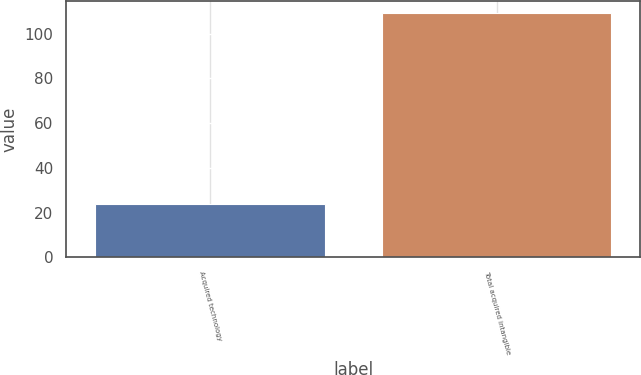<chart> <loc_0><loc_0><loc_500><loc_500><bar_chart><fcel>Acquired technology<fcel>Total acquired intangible<nl><fcel>24<fcel>109<nl></chart> 